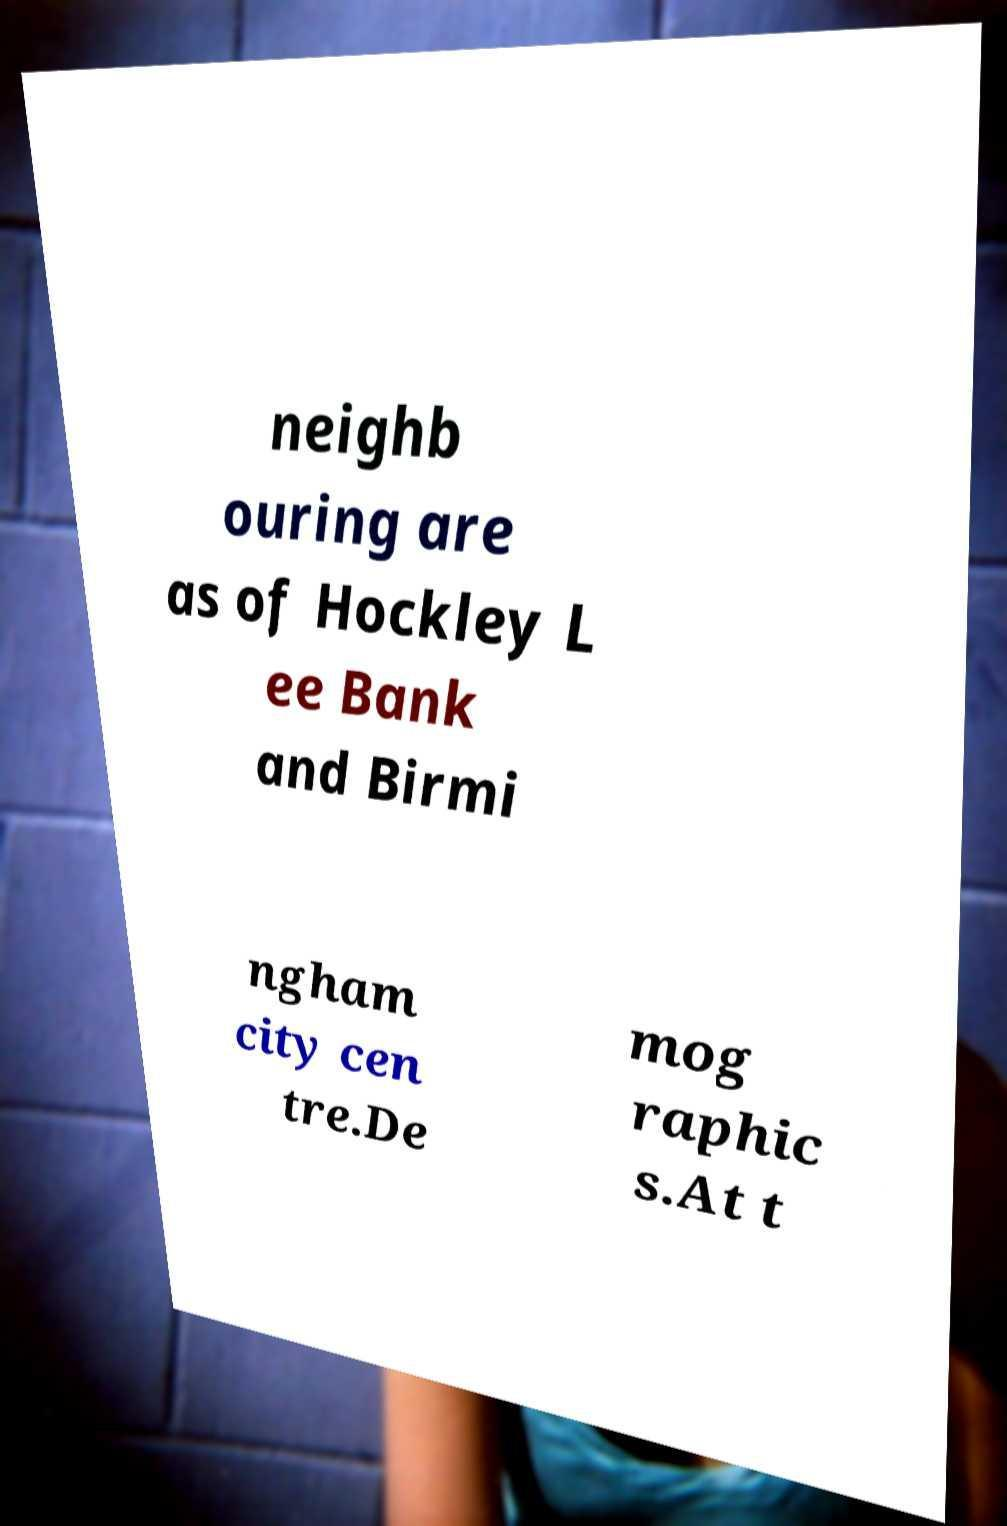For documentation purposes, I need the text within this image transcribed. Could you provide that? neighb ouring are as of Hockley L ee Bank and Birmi ngham city cen tre.De mog raphic s.At t 